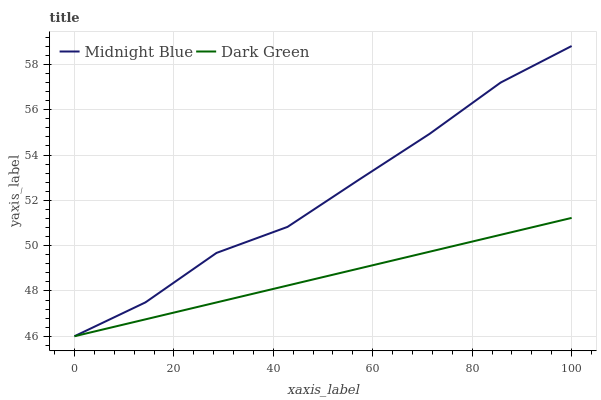Does Dark Green have the minimum area under the curve?
Answer yes or no. Yes. Does Midnight Blue have the maximum area under the curve?
Answer yes or no. Yes. Does Dark Green have the maximum area under the curve?
Answer yes or no. No. Is Dark Green the smoothest?
Answer yes or no. Yes. Is Midnight Blue the roughest?
Answer yes or no. Yes. Is Dark Green the roughest?
Answer yes or no. No. Does Midnight Blue have the lowest value?
Answer yes or no. Yes. Does Midnight Blue have the highest value?
Answer yes or no. Yes. Does Dark Green have the highest value?
Answer yes or no. No. Does Midnight Blue intersect Dark Green?
Answer yes or no. Yes. Is Midnight Blue less than Dark Green?
Answer yes or no. No. Is Midnight Blue greater than Dark Green?
Answer yes or no. No. 